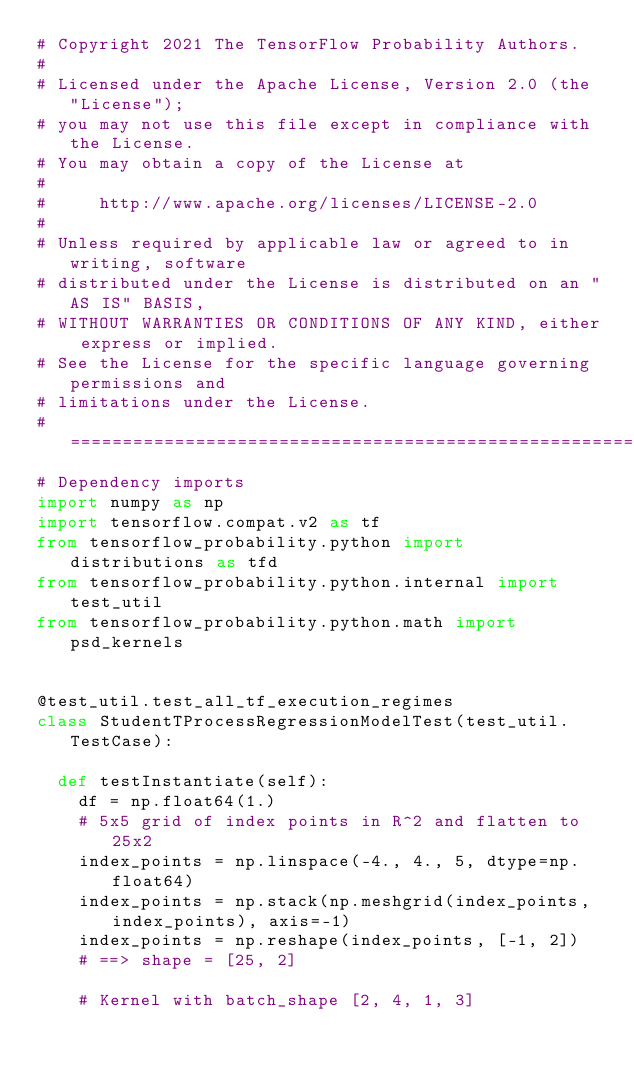<code> <loc_0><loc_0><loc_500><loc_500><_Python_># Copyright 2021 The TensorFlow Probability Authors.
#
# Licensed under the Apache License, Version 2.0 (the "License");
# you may not use this file except in compliance with the License.
# You may obtain a copy of the License at
#
#     http://www.apache.org/licenses/LICENSE-2.0
#
# Unless required by applicable law or agreed to in writing, software
# distributed under the License is distributed on an "AS IS" BASIS,
# WITHOUT WARRANTIES OR CONDITIONS OF ANY KIND, either express or implied.
# See the License for the specific language governing permissions and
# limitations under the License.
# ============================================================================
# Dependency imports
import numpy as np
import tensorflow.compat.v2 as tf
from tensorflow_probability.python import distributions as tfd
from tensorflow_probability.python.internal import test_util
from tensorflow_probability.python.math import psd_kernels


@test_util.test_all_tf_execution_regimes
class StudentTProcessRegressionModelTest(test_util.TestCase):

  def testInstantiate(self):
    df = np.float64(1.)
    # 5x5 grid of index points in R^2 and flatten to 25x2
    index_points = np.linspace(-4., 4., 5, dtype=np.float64)
    index_points = np.stack(np.meshgrid(index_points, index_points), axis=-1)
    index_points = np.reshape(index_points, [-1, 2])
    # ==> shape = [25, 2]

    # Kernel with batch_shape [2, 4, 1, 3]</code> 